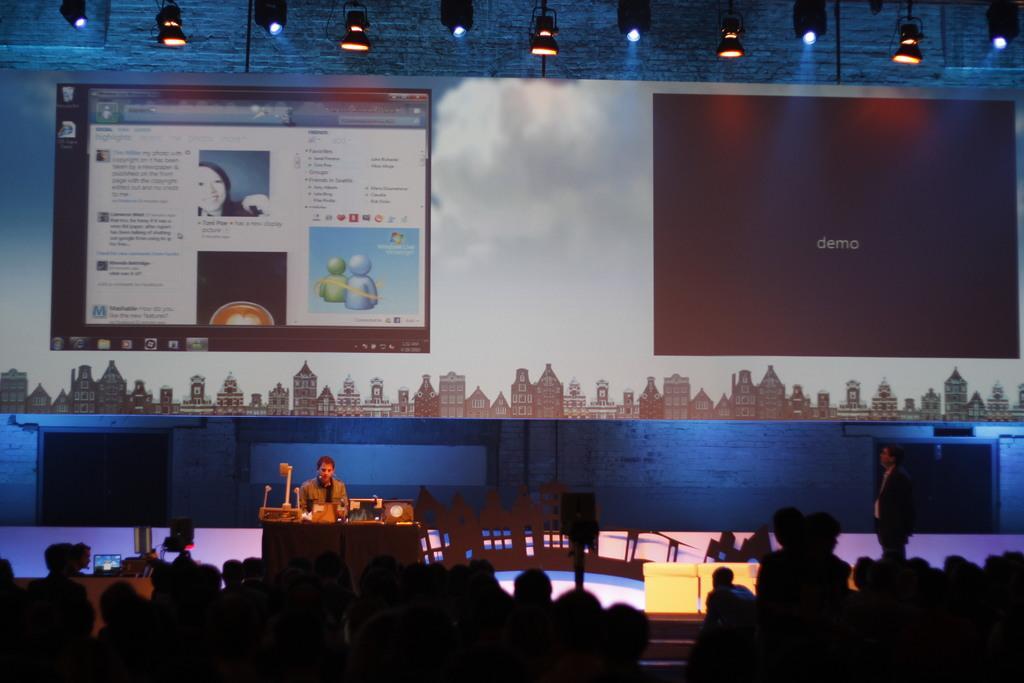Could you give a brief overview of what you see in this image? In this image I can see the group of people. In-front of these people I can see one person sitting in-front of the table. On the table I can see many things. In the background I can see the screens and many lights. 